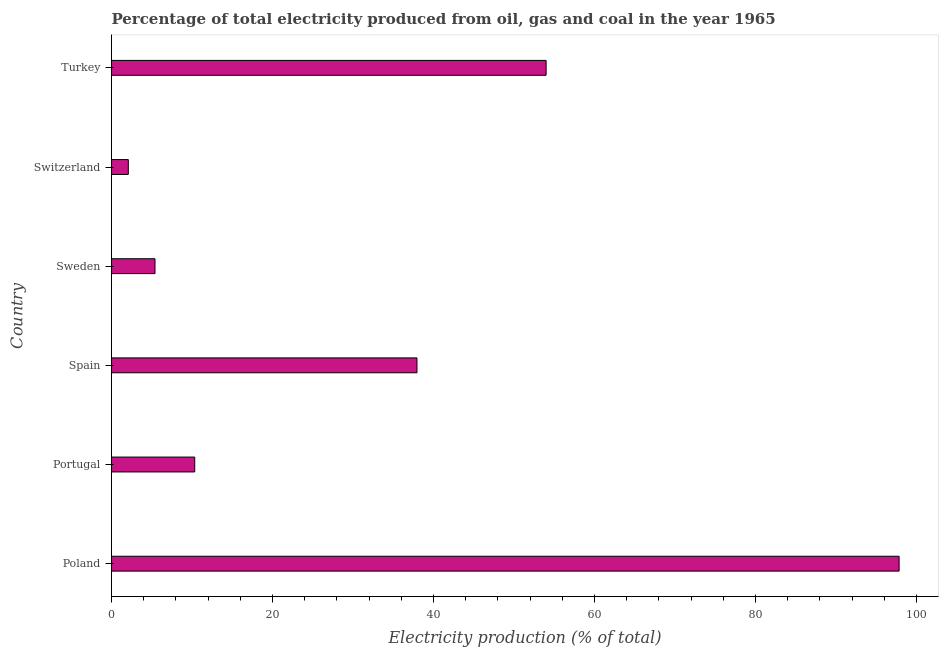Does the graph contain any zero values?
Your response must be concise. No. Does the graph contain grids?
Give a very brief answer. No. What is the title of the graph?
Offer a terse response. Percentage of total electricity produced from oil, gas and coal in the year 1965. What is the label or title of the X-axis?
Provide a short and direct response. Electricity production (% of total). What is the electricity production in Switzerland?
Provide a short and direct response. 2.08. Across all countries, what is the maximum electricity production?
Provide a short and direct response. 97.84. Across all countries, what is the minimum electricity production?
Provide a succinct answer. 2.08. In which country was the electricity production minimum?
Ensure brevity in your answer.  Switzerland. What is the sum of the electricity production?
Offer a terse response. 207.59. What is the difference between the electricity production in Spain and Switzerland?
Your response must be concise. 35.86. What is the average electricity production per country?
Give a very brief answer. 34.6. What is the median electricity production?
Make the answer very short. 24.14. What is the ratio of the electricity production in Sweden to that in Switzerland?
Give a very brief answer. 2.59. Is the difference between the electricity production in Switzerland and Turkey greater than the difference between any two countries?
Your answer should be very brief. No. What is the difference between the highest and the second highest electricity production?
Make the answer very short. 43.86. Is the sum of the electricity production in Spain and Switzerland greater than the maximum electricity production across all countries?
Your response must be concise. No. What is the difference between the highest and the lowest electricity production?
Offer a terse response. 95.76. In how many countries, is the electricity production greater than the average electricity production taken over all countries?
Keep it short and to the point. 3. Are all the bars in the graph horizontal?
Offer a terse response. Yes. How many countries are there in the graph?
Your answer should be very brief. 6. What is the difference between two consecutive major ticks on the X-axis?
Offer a terse response. 20. Are the values on the major ticks of X-axis written in scientific E-notation?
Ensure brevity in your answer.  No. What is the Electricity production (% of total) in Poland?
Your answer should be very brief. 97.84. What is the Electricity production (% of total) of Portugal?
Provide a short and direct response. 10.33. What is the Electricity production (% of total) in Spain?
Give a very brief answer. 37.94. What is the Electricity production (% of total) of Sweden?
Your answer should be compact. 5.4. What is the Electricity production (% of total) in Switzerland?
Offer a terse response. 2.08. What is the Electricity production (% of total) of Turkey?
Ensure brevity in your answer.  53.99. What is the difference between the Electricity production (% of total) in Poland and Portugal?
Offer a very short reply. 87.51. What is the difference between the Electricity production (% of total) in Poland and Spain?
Provide a short and direct response. 59.9. What is the difference between the Electricity production (% of total) in Poland and Sweden?
Offer a very short reply. 92.45. What is the difference between the Electricity production (% of total) in Poland and Switzerland?
Provide a succinct answer. 95.76. What is the difference between the Electricity production (% of total) in Poland and Turkey?
Offer a very short reply. 43.86. What is the difference between the Electricity production (% of total) in Portugal and Spain?
Offer a terse response. -27.61. What is the difference between the Electricity production (% of total) in Portugal and Sweden?
Offer a terse response. 4.94. What is the difference between the Electricity production (% of total) in Portugal and Switzerland?
Your answer should be very brief. 8.25. What is the difference between the Electricity production (% of total) in Portugal and Turkey?
Offer a very short reply. -43.65. What is the difference between the Electricity production (% of total) in Spain and Sweden?
Your response must be concise. 32.55. What is the difference between the Electricity production (% of total) in Spain and Switzerland?
Offer a terse response. 35.86. What is the difference between the Electricity production (% of total) in Spain and Turkey?
Offer a very short reply. -16.04. What is the difference between the Electricity production (% of total) in Sweden and Switzerland?
Provide a succinct answer. 3.32. What is the difference between the Electricity production (% of total) in Sweden and Turkey?
Give a very brief answer. -48.59. What is the difference between the Electricity production (% of total) in Switzerland and Turkey?
Offer a terse response. -51.91. What is the ratio of the Electricity production (% of total) in Poland to that in Portugal?
Your response must be concise. 9.47. What is the ratio of the Electricity production (% of total) in Poland to that in Spain?
Provide a succinct answer. 2.58. What is the ratio of the Electricity production (% of total) in Poland to that in Sweden?
Make the answer very short. 18.13. What is the ratio of the Electricity production (% of total) in Poland to that in Switzerland?
Your answer should be compact. 47.02. What is the ratio of the Electricity production (% of total) in Poland to that in Turkey?
Your answer should be very brief. 1.81. What is the ratio of the Electricity production (% of total) in Portugal to that in Spain?
Offer a terse response. 0.27. What is the ratio of the Electricity production (% of total) in Portugal to that in Sweden?
Keep it short and to the point. 1.92. What is the ratio of the Electricity production (% of total) in Portugal to that in Switzerland?
Give a very brief answer. 4.97. What is the ratio of the Electricity production (% of total) in Portugal to that in Turkey?
Offer a terse response. 0.19. What is the ratio of the Electricity production (% of total) in Spain to that in Sweden?
Ensure brevity in your answer.  7.03. What is the ratio of the Electricity production (% of total) in Spain to that in Switzerland?
Offer a very short reply. 18.23. What is the ratio of the Electricity production (% of total) in Spain to that in Turkey?
Keep it short and to the point. 0.7. What is the ratio of the Electricity production (% of total) in Sweden to that in Switzerland?
Your answer should be very brief. 2.59. What is the ratio of the Electricity production (% of total) in Switzerland to that in Turkey?
Your answer should be very brief. 0.04. 